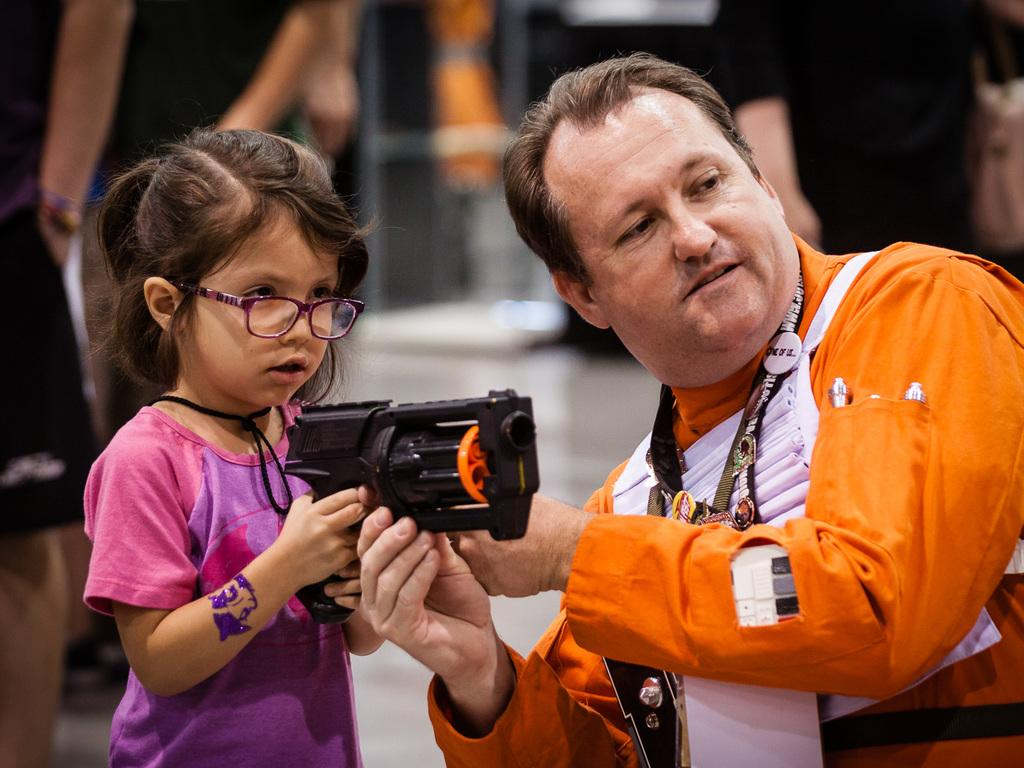Who are the people in the image? There is a man and a girl in the image. What are the man and the girl holding in the image? The man and the girl are holding a toy gun. Can you describe the people visible in the background of the image? There are people visible in the background of the image, but their specific characteristics are not mentioned in the provided facts. What type of prison can be seen in the background of the image? There is no prison present in the image; it features a man and a girl holding a toy gun, with people visible in the background. 